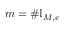<formula> <loc_0><loc_0><loc_500><loc_500>m = \# \mathbb { I } _ { M , e }</formula> 